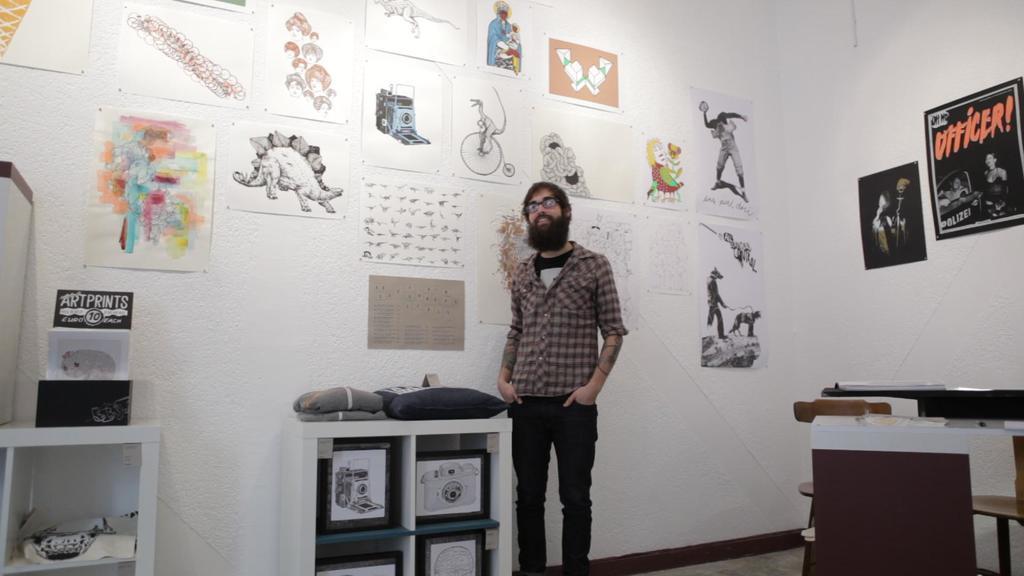Please provide a concise description of this image. In this image I see a man who is standing in front of the wall and he is smiling. I can also see there are racks and few things in it. In the background i see few arts and posters. 